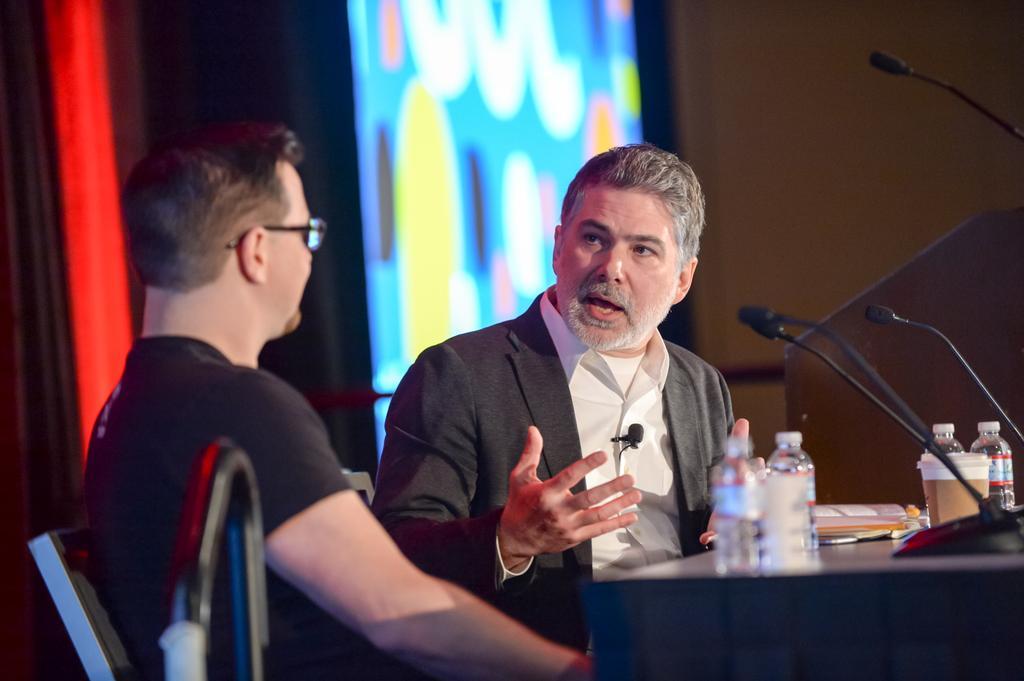Can you describe this image briefly? In this picture there is a man who is wearing blazer and shirt. On his shirt there is a mic. On the left there is another man who is wearing spectacle and black t-shirt. He is sitting on the chair. On the right I can see the water bottles, cups, files, papers and mics. In the background I can see the projector screen which is placed near to the wall. In the top left I can see the red light. 